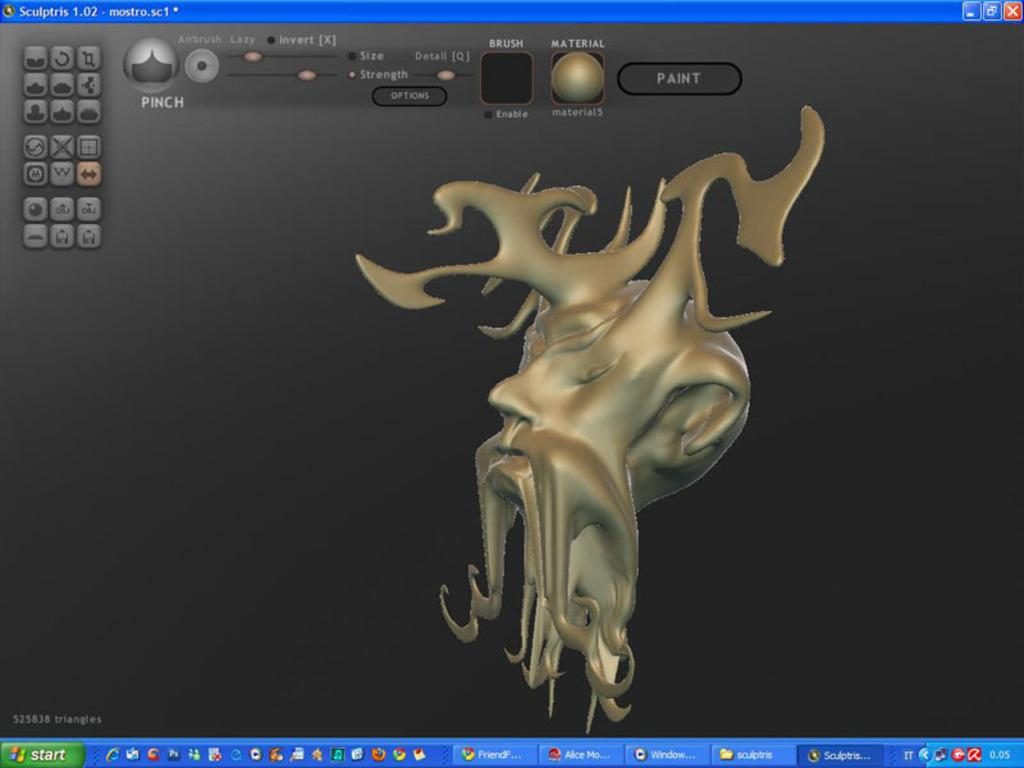What is the main object in the image? There is a screen in the image. What can be seen on the screen? The screen contains icons and an image. How many women are present in the image? There is no reference to any women in the image; it only features a screen with icons and an image. What type of brake can be seen on the screen? There is no brake present on the screen; it only contains icons and an image. 